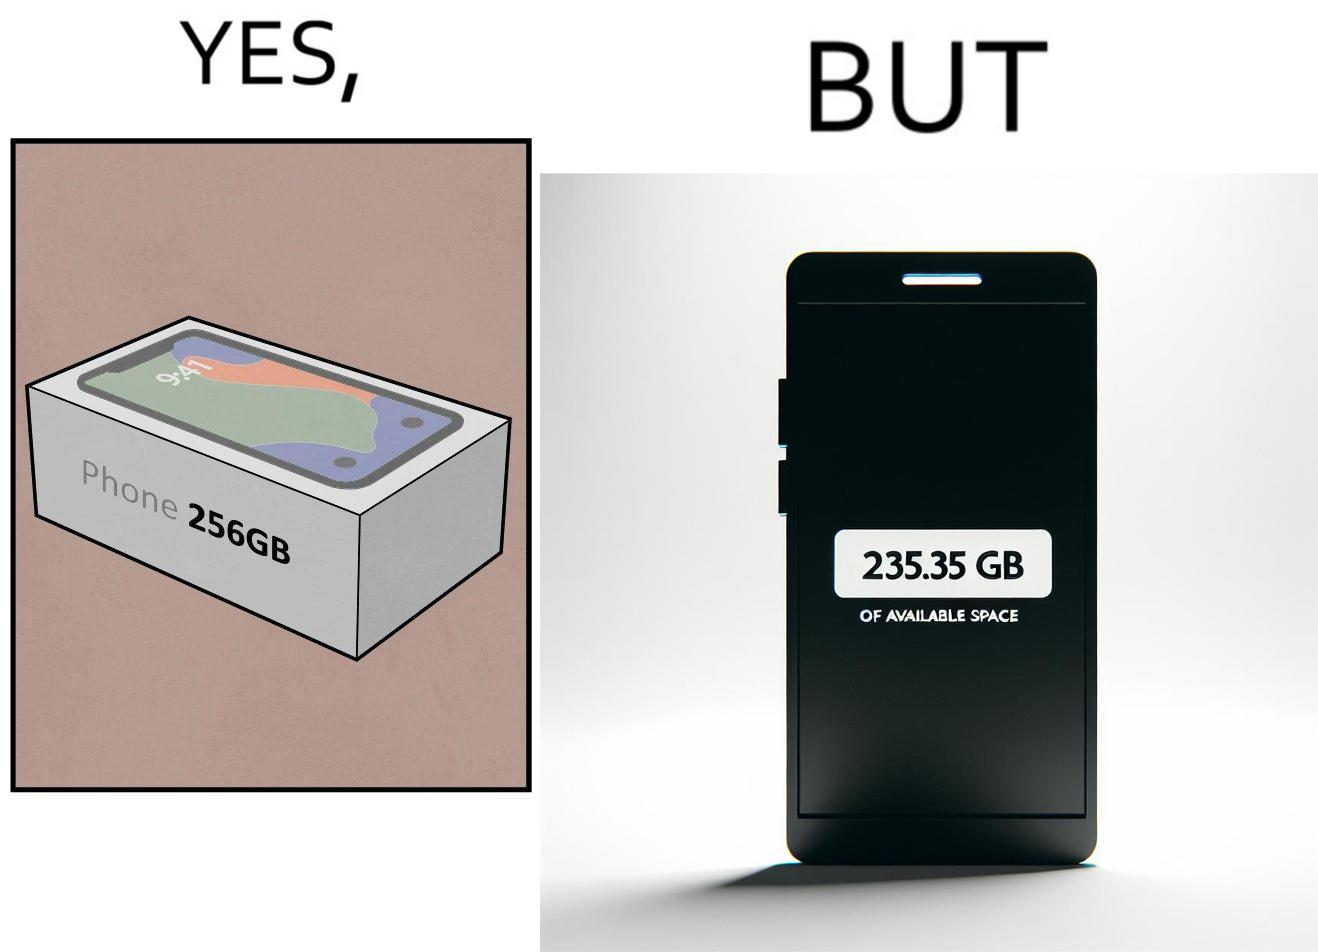What is shown in the left half versus the right half of this image? In the left part of the image: It is a smartphone box claiming the phone has a storage capacity of 256 gb In the right part of the image: It is a smartphone with 235.35 gb of available space 